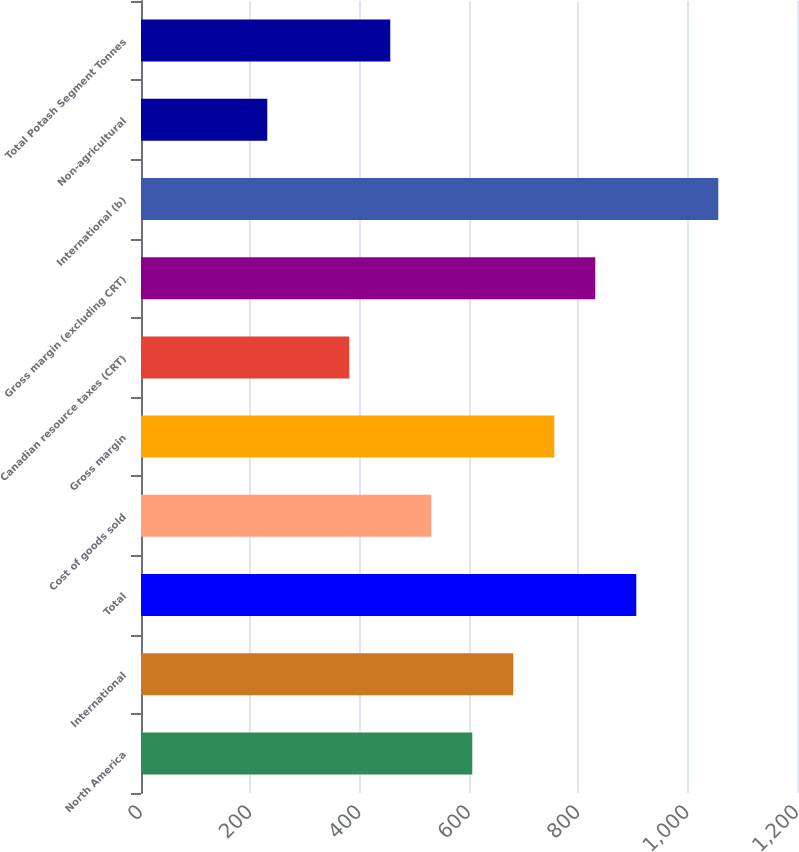<chart> <loc_0><loc_0><loc_500><loc_500><bar_chart><fcel>North America<fcel>International<fcel>Total<fcel>Cost of goods sold<fcel>Gross margin<fcel>Canadian resource taxes (CRT)<fcel>Gross margin (excluding CRT)<fcel>International (b)<fcel>Non-agricultural<fcel>Total Potash Segment Tonnes<nl><fcel>606<fcel>681<fcel>906<fcel>531<fcel>756<fcel>381<fcel>831<fcel>1056<fcel>231<fcel>456<nl></chart> 